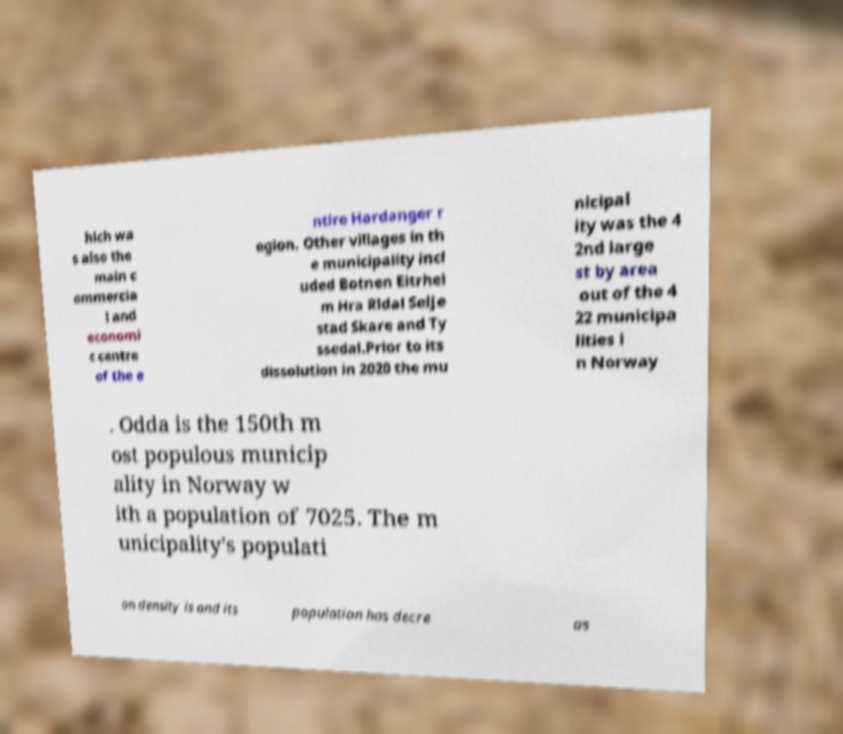Could you extract and type out the text from this image? hich wa s also the main c ommercia l and economi c centre of the e ntire Hardanger r egion. Other villages in th e municipality incl uded Botnen Eitrhei m Hra Rldal Selje stad Skare and Ty ssedal.Prior to its dissolution in 2020 the mu nicipal ity was the 4 2nd large st by area out of the 4 22 municipa lities i n Norway . Odda is the 150th m ost populous municip ality in Norway w ith a population of 7025. The m unicipality's populati on density is and its population has decre as 